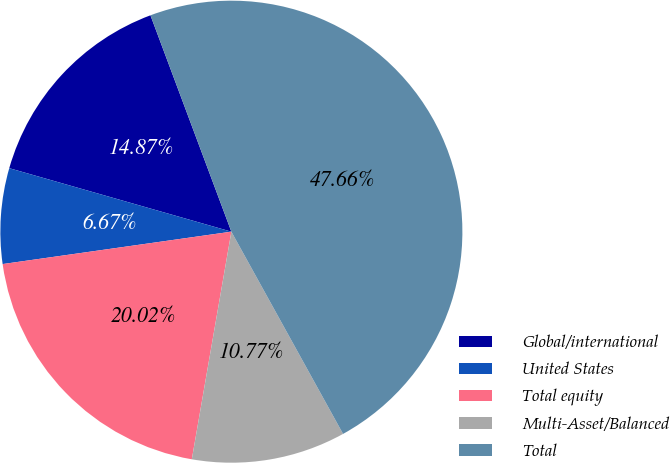<chart> <loc_0><loc_0><loc_500><loc_500><pie_chart><fcel>Global/international<fcel>United States<fcel>Total equity<fcel>Multi-Asset/Balanced<fcel>Total<nl><fcel>14.87%<fcel>6.67%<fcel>20.02%<fcel>10.77%<fcel>47.66%<nl></chart> 